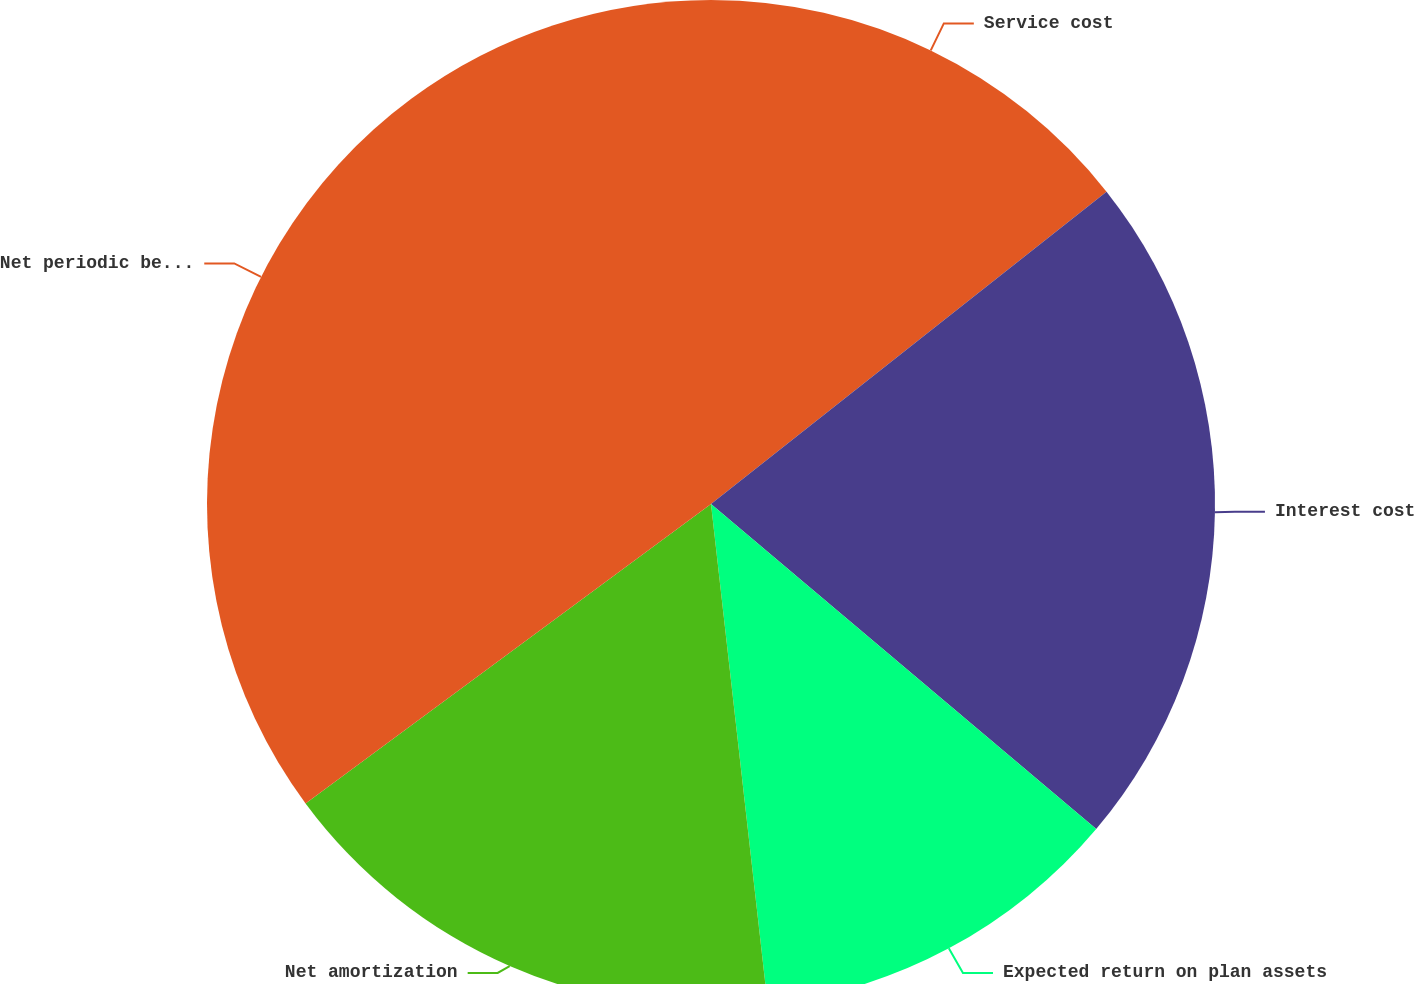<chart> <loc_0><loc_0><loc_500><loc_500><pie_chart><fcel>Service cost<fcel>Interest cost<fcel>Expected return on plan assets<fcel>Net amortization<fcel>Net periodic benefit cost<nl><fcel>14.36%<fcel>21.79%<fcel>12.05%<fcel>16.67%<fcel>35.12%<nl></chart> 